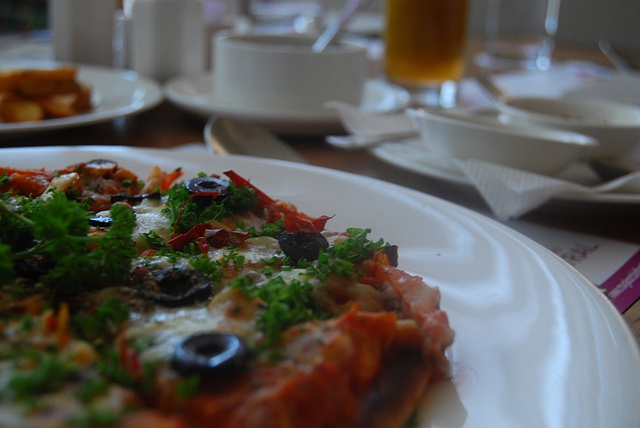Describe the objects in this image and their specific colors. I can see pizza in black, maroon, gray, and olive tones, dining table in black, gray, and darkgray tones, bowl in black, maroon, and gray tones, bowl in black and gray tones, and bowl in black and gray tones in this image. 